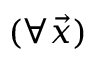<formula> <loc_0><loc_0><loc_500><loc_500>( \forall \ V e c { x } )</formula> 